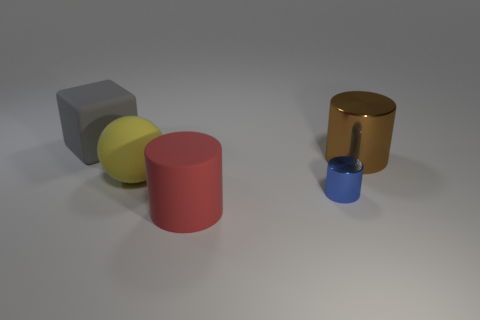Is there any other thing that has the same size as the brown metal object?
Your answer should be compact. Yes. What is the color of the big cylinder that is to the left of the big cylinder that is to the right of the large red thing?
Keep it short and to the point. Red. There is a shiny object left of the metallic object that is behind the metal thing that is in front of the yellow rubber object; what shape is it?
Ensure brevity in your answer.  Cylinder. There is a object that is on the right side of the big yellow matte sphere and on the left side of the blue metallic cylinder; how big is it?
Offer a terse response. Large. What material is the gray block?
Provide a succinct answer. Rubber. Do the large object that is right of the large red cylinder and the small blue thing have the same material?
Your response must be concise. Yes. There is a big thing that is behind the large brown metal thing; what shape is it?
Offer a terse response. Cube. There is a sphere that is the same size as the red thing; what is its material?
Make the answer very short. Rubber. How many things are metal objects that are in front of the large yellow matte object or large objects that are to the left of the tiny blue thing?
Your response must be concise. 4. There is a blue cylinder that is made of the same material as the brown object; what is its size?
Your response must be concise. Small. 